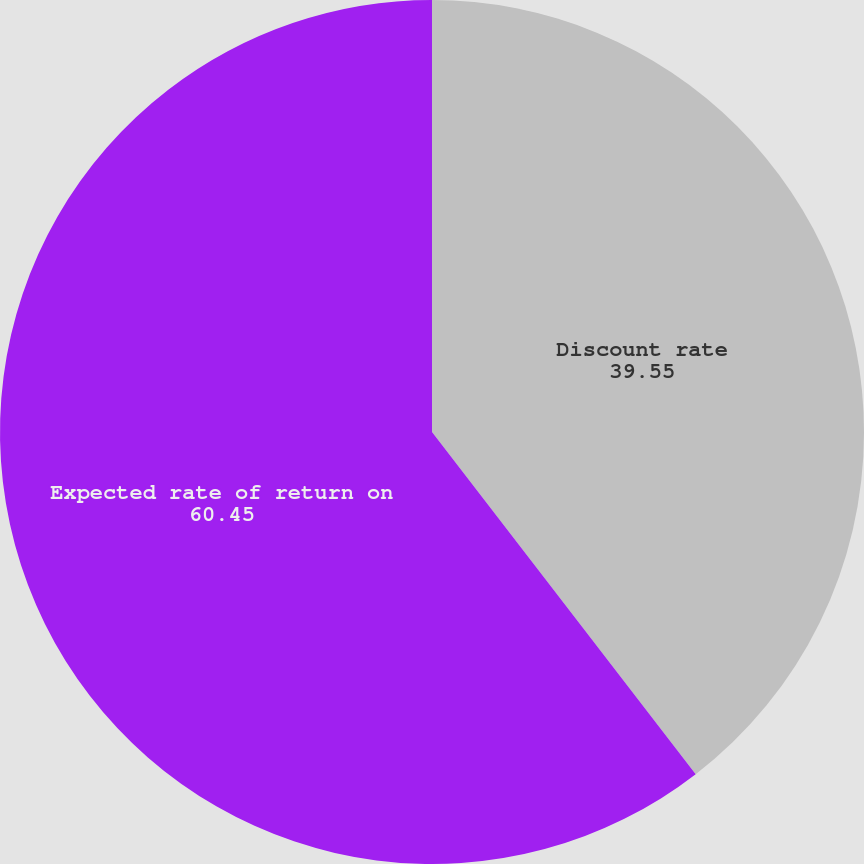Convert chart. <chart><loc_0><loc_0><loc_500><loc_500><pie_chart><fcel>Discount rate<fcel>Expected rate of return on<nl><fcel>39.55%<fcel>60.45%<nl></chart> 